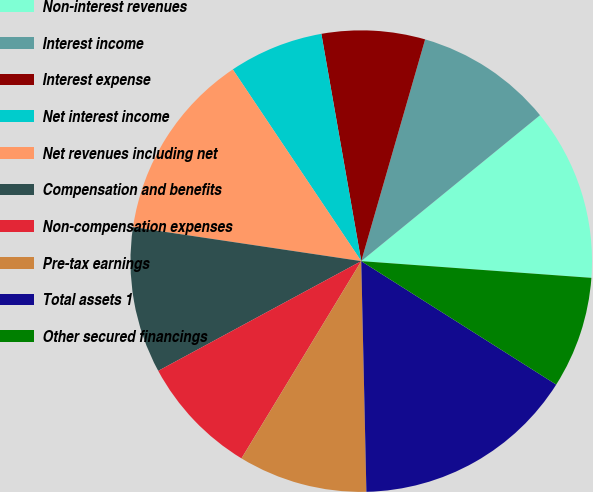Convert chart to OTSL. <chart><loc_0><loc_0><loc_500><loc_500><pie_chart><fcel>Non-interest revenues<fcel>Interest income<fcel>Interest expense<fcel>Net interest income<fcel>Net revenues including net<fcel>Compensation and benefits<fcel>Non-compensation expenses<fcel>Pre-tax earnings<fcel>Total assets 1<fcel>Other secured financings<nl><fcel>12.05%<fcel>9.64%<fcel>7.23%<fcel>6.63%<fcel>13.25%<fcel>10.24%<fcel>8.43%<fcel>9.04%<fcel>15.66%<fcel>7.83%<nl></chart> 